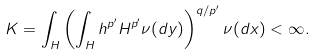<formula> <loc_0><loc_0><loc_500><loc_500>K = \int _ { H } \left ( \int _ { H } h ^ { p ^ { \prime } } H ^ { p ^ { \prime } } \nu ( d y ) \right ) ^ { q / p ^ { \prime } } \nu ( d x ) < \infty .</formula> 